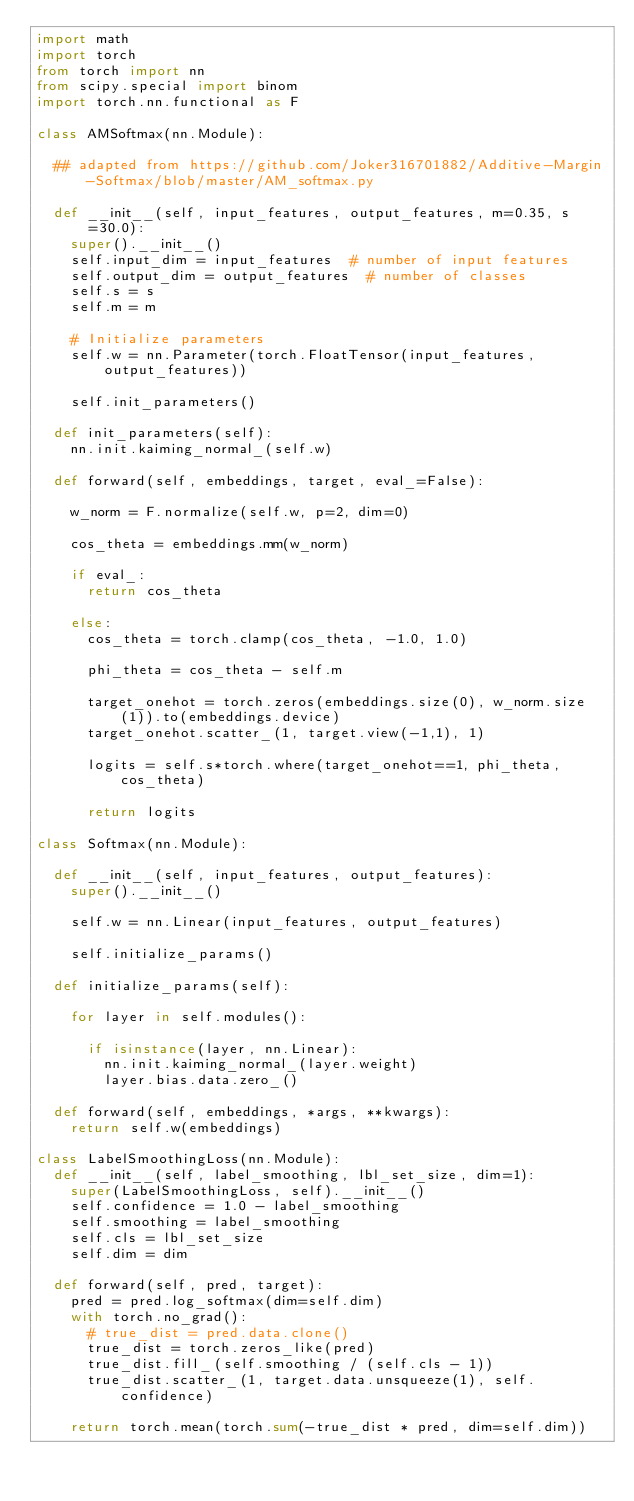Convert code to text. <code><loc_0><loc_0><loc_500><loc_500><_Python_>import math
import torch
from torch import nn
from scipy.special import binom
import torch.nn.functional as F

class AMSoftmax(nn.Module):

	## adapted from https://github.com/Joker316701882/Additive-Margin-Softmax/blob/master/AM_softmax.py

	def __init__(self, input_features, output_features, m=0.35, s=30.0):
		super().__init__()
		self.input_dim = input_features  # number of input features
		self.output_dim = output_features  # number of classes
		self.s = s
		self.m = m

		# Initialize parameters
		self.w = nn.Parameter(torch.FloatTensor(input_features, output_features))

		self.init_parameters()

	def init_parameters(self):
		nn.init.kaiming_normal_(self.w)

	def forward(self, embeddings, target, eval_=False):

		w_norm = F.normalize(self.w, p=2, dim=0)

		cos_theta = embeddings.mm(w_norm)

		if eval_:
			return cos_theta

		else:
			cos_theta = torch.clamp(cos_theta, -1.0, 1.0)

			phi_theta = cos_theta - self.m

			target_onehot = torch.zeros(embeddings.size(0), w_norm.size(1)).to(embeddings.device)
			target_onehot.scatter_(1, target.view(-1,1), 1)

			logits = self.s*torch.where(target_onehot==1, phi_theta, cos_theta)

			return logits

class Softmax(nn.Module):

	def __init__(self, input_features, output_features):
		super().__init__()

		self.w = nn.Linear(input_features, output_features)

		self.initialize_params()

	def initialize_params(self):

		for layer in self.modules():

			if isinstance(layer, nn.Linear):
				nn.init.kaiming_normal_(layer.weight)
				layer.bias.data.zero_()

	def forward(self, embeddings, *args, **kwargs):
		return self.w(embeddings)

class LabelSmoothingLoss(nn.Module):
	def __init__(self, label_smoothing, lbl_set_size, dim=1):
		super(LabelSmoothingLoss, self).__init__()
		self.confidence = 1.0 - label_smoothing
		self.smoothing = label_smoothing
		self.cls = lbl_set_size
		self.dim = dim

	def forward(self, pred, target):
		pred = pred.log_softmax(dim=self.dim)
		with torch.no_grad():
			# true_dist = pred.data.clone()
			true_dist = torch.zeros_like(pred)
			true_dist.fill_(self.smoothing / (self.cls - 1))
			true_dist.scatter_(1, target.data.unsqueeze(1), self.confidence)

		return torch.mean(torch.sum(-true_dist * pred, dim=self.dim))
</code> 